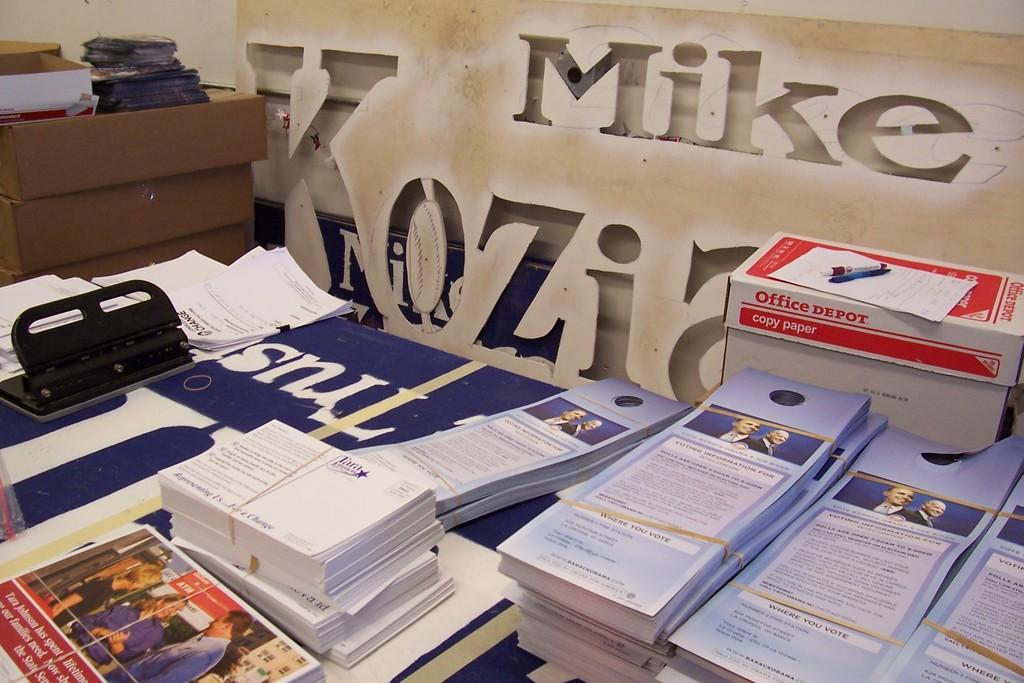<image>
Create a compact narrative representing the image presented. The name on the wall behind the papers is Mike 